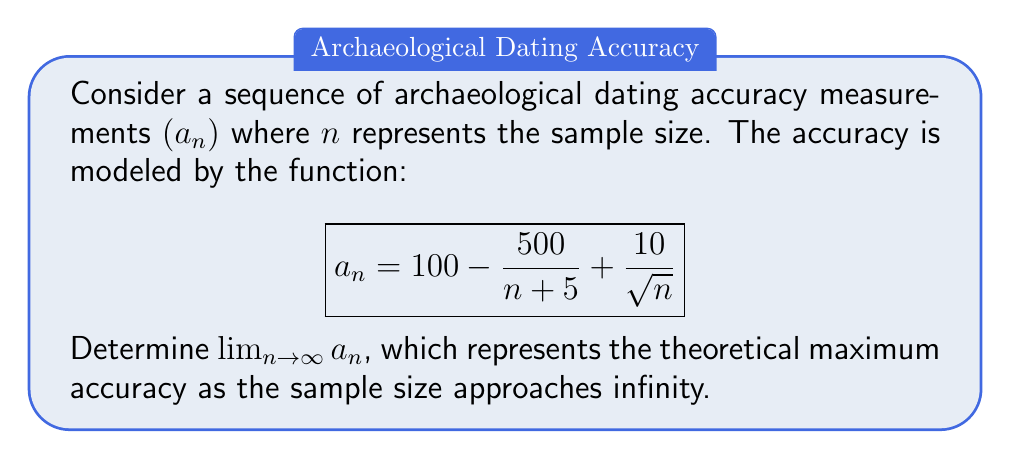Can you solve this math problem? To find the limit of the sequence as $n$ approaches infinity, we need to evaluate each term of the function separately:

1. The constant term: $100$ remains unchanged as $n$ approaches infinity.

2. For the term $\frac{500}{n + 5}$:
   As $n \to \infty$, $(n + 5) \to \infty$, so $\frac{500}{n + 5} \to 0$.

3. For the term $\frac{10}{\sqrt{n}}$:
   As $n \to \infty$, $\sqrt{n} \to \infty$, so $\frac{10}{\sqrt{n}} \to 0$.

Now, we can write:

$$\lim_{n \to \infty} a_n = \lim_{n \to \infty} \left(100 - \frac{500}{n + 5} + \frac{10}{\sqrt{n}}\right)$$

Applying the limit to each term:

$$\lim_{n \to \infty} a_n = 100 - \lim_{n \to \infty}\frac{500}{n + 5} + \lim_{n \to \infty}\frac{10}{\sqrt{n}}$$

$$\lim_{n \to \infty} a_n = 100 - 0 + 0 = 100$$

Therefore, the theoretical maximum accuracy as the sample size approaches infinity is 100%.
Answer: $\lim_{n \to \infty} a_n = 100$ 